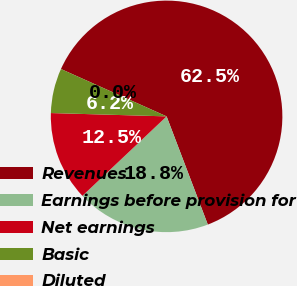Convert chart. <chart><loc_0><loc_0><loc_500><loc_500><pie_chart><fcel>Revenues<fcel>Earnings before provision for<fcel>Net earnings<fcel>Basic<fcel>Diluted<nl><fcel>62.5%<fcel>18.75%<fcel>12.5%<fcel>6.25%<fcel>0.0%<nl></chart> 